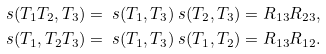<formula> <loc_0><loc_0><loc_500><loc_500>\ s ( T _ { 1 } T _ { 2 } , T _ { 3 } ) & = \ s ( T _ { 1 } , T _ { 3 } ) \ s ( T _ { 2 } , T _ { 3 } ) = R _ { 1 3 } R _ { 2 3 } , \\ \ s ( T _ { 1 } , T _ { 2 } T _ { 3 } ) & = \ s ( T _ { 1 } , T _ { 3 } ) \ s ( T _ { 1 } , T _ { 2 } ) = R _ { 1 3 } R _ { 1 2 } .</formula> 